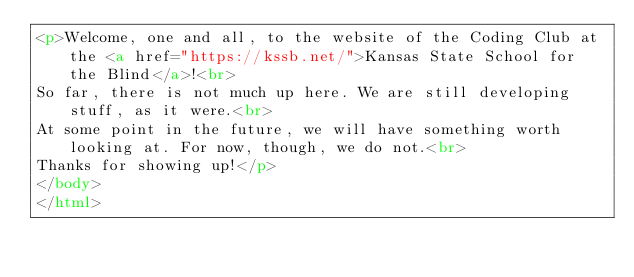<code> <loc_0><loc_0><loc_500><loc_500><_HTML_><p>Welcome, one and all, to the website of the Coding Club at the <a href="https://kssb.net/">Kansas State School for the Blind</a>!<br>
So far, there is not much up here. We are still developing stuff, as it were.<br>
At some point in the future, we will have something worth looking at. For now, though, we do not.<br>
Thanks for showing up!</p>
</body>
</html>
</code> 